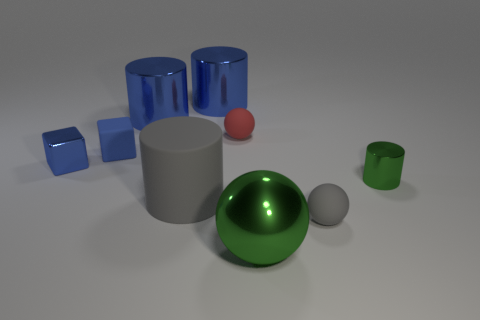There is a green metallic thing that is the same shape as the large gray object; what size is it?
Provide a succinct answer. Small. What number of other things are the same material as the tiny red thing?
Make the answer very short. 3. What is the material of the gray ball?
Offer a very short reply. Rubber. Does the matte sphere behind the small blue rubber block have the same color as the sphere that is right of the big green sphere?
Make the answer very short. No. Is the number of tiny rubber blocks that are on the left side of the green shiny sphere greater than the number of blue shiny cylinders?
Provide a short and direct response. No. What number of other objects are there of the same color as the shiny cube?
Your answer should be very brief. 3. Is the size of the green thing that is in front of the green metallic cylinder the same as the small red rubber ball?
Keep it short and to the point. No. Is there a blue rubber thing that has the same size as the gray sphere?
Ensure brevity in your answer.  Yes. There is a tiny metal object that is on the left side of the tiny green cylinder; what color is it?
Make the answer very short. Blue. There is a object that is to the right of the matte cylinder and behind the red rubber object; what shape is it?
Your answer should be compact. Cylinder. 